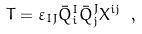<formula> <loc_0><loc_0><loc_500><loc_500>T = \varepsilon _ { I J } \bar { Q } ^ { I } _ { i } \bar { Q } ^ { J } _ { j } X ^ { i j } \ ,</formula> 